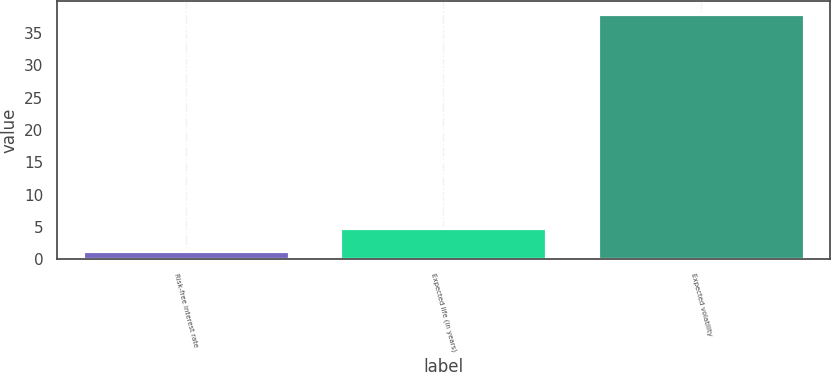Convert chart. <chart><loc_0><loc_0><loc_500><loc_500><bar_chart><fcel>Risk-free interest rate<fcel>Expected life (in years)<fcel>Expected volatility<nl><fcel>1.2<fcel>4.88<fcel>38<nl></chart> 